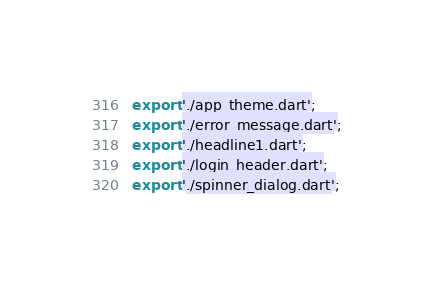<code> <loc_0><loc_0><loc_500><loc_500><_Dart_>export './app_theme.dart';
export './error_message.dart';
export './headline1.dart';
export './login_header.dart';
export './spinner_dialog.dart';
</code> 